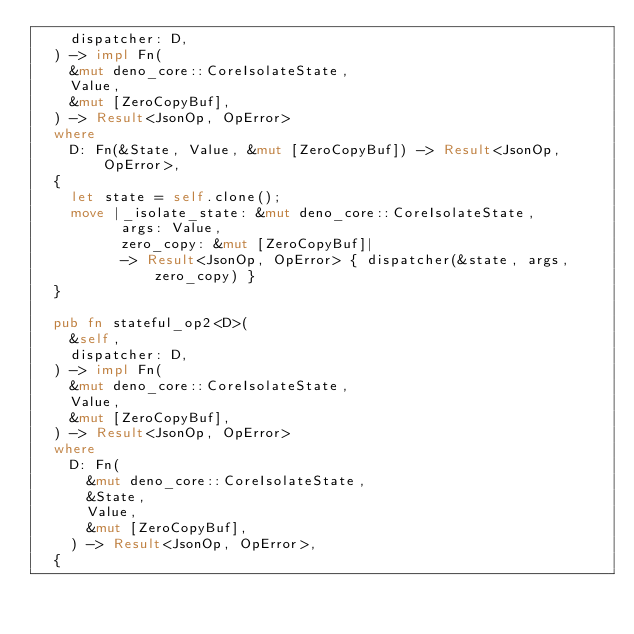<code> <loc_0><loc_0><loc_500><loc_500><_Rust_>    dispatcher: D,
  ) -> impl Fn(
    &mut deno_core::CoreIsolateState,
    Value,
    &mut [ZeroCopyBuf],
  ) -> Result<JsonOp, OpError>
  where
    D: Fn(&State, Value, &mut [ZeroCopyBuf]) -> Result<JsonOp, OpError>,
  {
    let state = self.clone();
    move |_isolate_state: &mut deno_core::CoreIsolateState,
          args: Value,
          zero_copy: &mut [ZeroCopyBuf]|
          -> Result<JsonOp, OpError> { dispatcher(&state, args, zero_copy) }
  }

  pub fn stateful_op2<D>(
    &self,
    dispatcher: D,
  ) -> impl Fn(
    &mut deno_core::CoreIsolateState,
    Value,
    &mut [ZeroCopyBuf],
  ) -> Result<JsonOp, OpError>
  where
    D: Fn(
      &mut deno_core::CoreIsolateState,
      &State,
      Value,
      &mut [ZeroCopyBuf],
    ) -> Result<JsonOp, OpError>,
  {</code> 